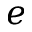Convert formula to latex. <formula><loc_0><loc_0><loc_500><loc_500>e</formula> 